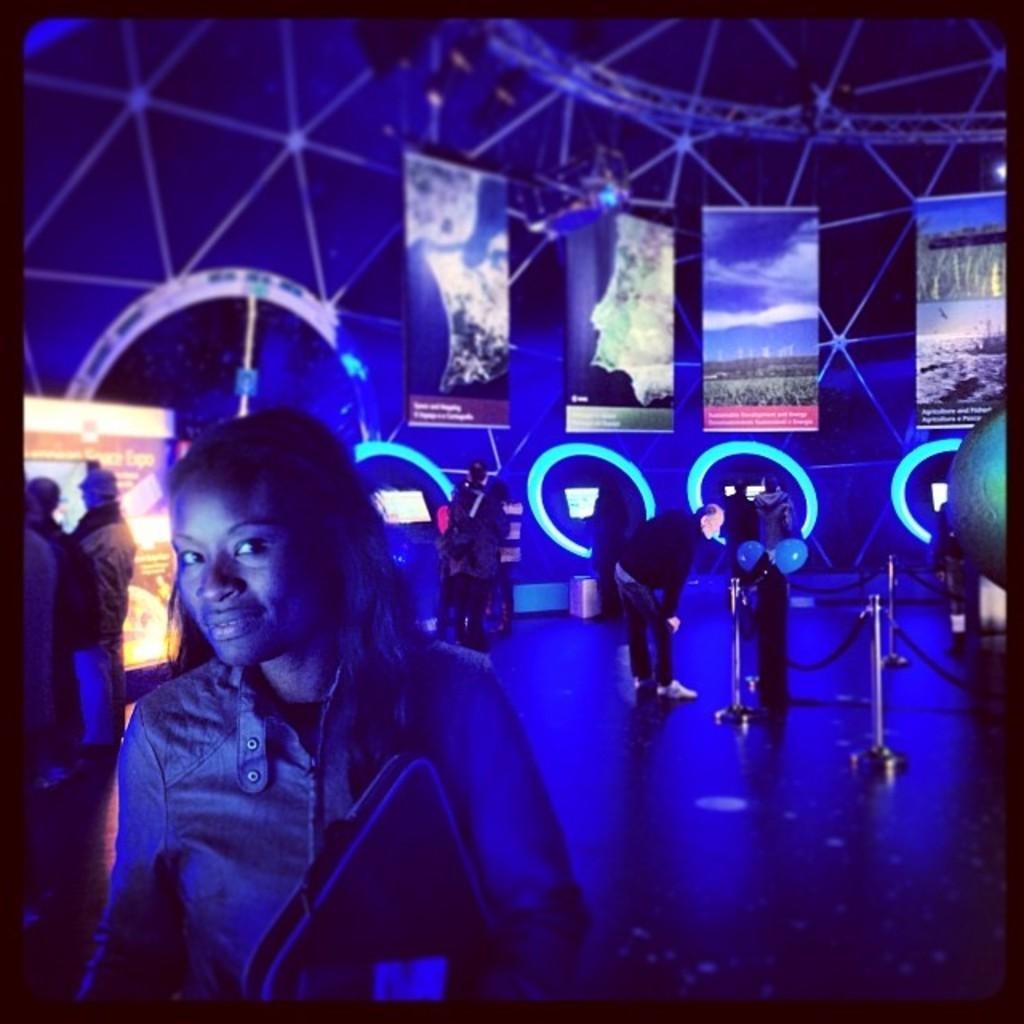Could you give a brief overview of what you see in this image? In this picture we can see group of people, in the foreground we can see a woman, she is holding a file, in the background we can see few hoardings, metal rods, lights and balloons. 